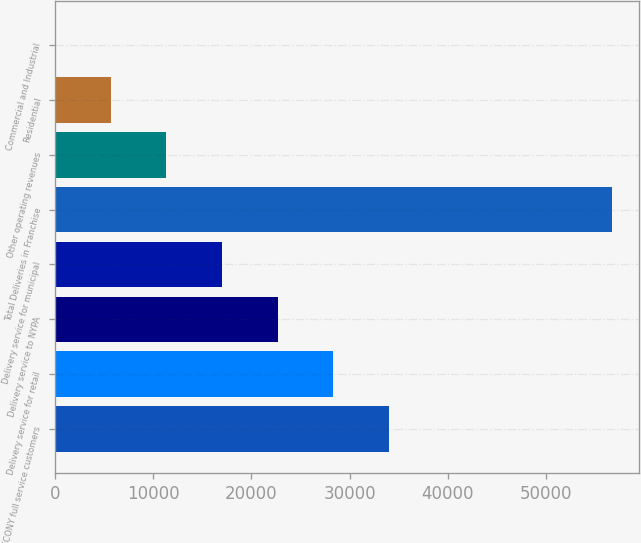Convert chart. <chart><loc_0><loc_0><loc_500><loc_500><bar_chart><fcel>CECONY full service customers<fcel>Delivery service for retail<fcel>Delivery service to NYPA<fcel>Delivery service for municipal<fcel>Total Deliveries in Franchise<fcel>Other operating revenues<fcel>Residential<fcel>Commercial and Industrial<nl><fcel>34008<fcel>28343.3<fcel>22678.6<fcel>17013.8<fcel>56667<fcel>11349.1<fcel>5684.34<fcel>19.6<nl></chart> 